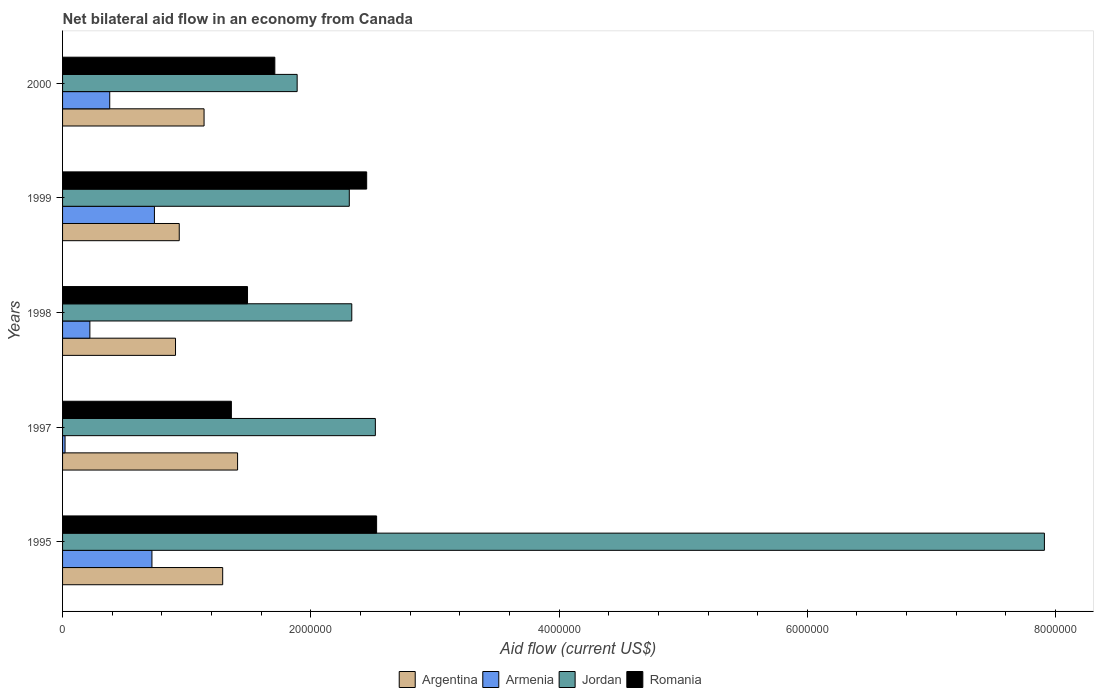How many different coloured bars are there?
Offer a very short reply. 4. How many groups of bars are there?
Keep it short and to the point. 5. How many bars are there on the 5th tick from the top?
Make the answer very short. 4. How many bars are there on the 1st tick from the bottom?
Provide a succinct answer. 4. What is the label of the 4th group of bars from the top?
Your answer should be compact. 1997. What is the net bilateral aid flow in Romania in 1997?
Provide a succinct answer. 1.36e+06. Across all years, what is the maximum net bilateral aid flow in Romania?
Provide a short and direct response. 2.53e+06. Across all years, what is the minimum net bilateral aid flow in Jordan?
Keep it short and to the point. 1.89e+06. In which year was the net bilateral aid flow in Armenia minimum?
Provide a succinct answer. 1997. What is the total net bilateral aid flow in Armenia in the graph?
Your answer should be very brief. 2.08e+06. What is the difference between the net bilateral aid flow in Armenia in 1995 and the net bilateral aid flow in Argentina in 1999?
Ensure brevity in your answer.  -2.20e+05. What is the average net bilateral aid flow in Romania per year?
Your answer should be very brief. 1.91e+06. In the year 1999, what is the difference between the net bilateral aid flow in Jordan and net bilateral aid flow in Armenia?
Make the answer very short. 1.57e+06. In how many years, is the net bilateral aid flow in Armenia greater than 800000 US$?
Your response must be concise. 0. What is the ratio of the net bilateral aid flow in Romania in 1997 to that in 1999?
Make the answer very short. 0.56. Is the net bilateral aid flow in Argentina in 1995 less than that in 2000?
Make the answer very short. No. What is the difference between the highest and the second highest net bilateral aid flow in Armenia?
Keep it short and to the point. 2.00e+04. What is the difference between the highest and the lowest net bilateral aid flow in Romania?
Keep it short and to the point. 1.17e+06. Is the sum of the net bilateral aid flow in Argentina in 1997 and 1998 greater than the maximum net bilateral aid flow in Armenia across all years?
Your response must be concise. Yes. What does the 3rd bar from the top in 2000 represents?
Provide a short and direct response. Armenia. What does the 4th bar from the bottom in 1995 represents?
Your response must be concise. Romania. How many bars are there?
Your response must be concise. 20. Are all the bars in the graph horizontal?
Your response must be concise. Yes. How many years are there in the graph?
Your response must be concise. 5. Are the values on the major ticks of X-axis written in scientific E-notation?
Your answer should be compact. No. How are the legend labels stacked?
Provide a short and direct response. Horizontal. What is the title of the graph?
Offer a terse response. Net bilateral aid flow in an economy from Canada. What is the label or title of the X-axis?
Your answer should be compact. Aid flow (current US$). What is the label or title of the Y-axis?
Your answer should be very brief. Years. What is the Aid flow (current US$) in Argentina in 1995?
Your answer should be compact. 1.29e+06. What is the Aid flow (current US$) in Armenia in 1995?
Offer a terse response. 7.20e+05. What is the Aid flow (current US$) of Jordan in 1995?
Your answer should be very brief. 7.91e+06. What is the Aid flow (current US$) of Romania in 1995?
Provide a succinct answer. 2.53e+06. What is the Aid flow (current US$) of Argentina in 1997?
Provide a succinct answer. 1.41e+06. What is the Aid flow (current US$) in Armenia in 1997?
Keep it short and to the point. 2.00e+04. What is the Aid flow (current US$) of Jordan in 1997?
Your response must be concise. 2.52e+06. What is the Aid flow (current US$) of Romania in 1997?
Provide a short and direct response. 1.36e+06. What is the Aid flow (current US$) of Argentina in 1998?
Give a very brief answer. 9.10e+05. What is the Aid flow (current US$) of Armenia in 1998?
Make the answer very short. 2.20e+05. What is the Aid flow (current US$) of Jordan in 1998?
Your response must be concise. 2.33e+06. What is the Aid flow (current US$) of Romania in 1998?
Ensure brevity in your answer.  1.49e+06. What is the Aid flow (current US$) of Argentina in 1999?
Offer a terse response. 9.40e+05. What is the Aid flow (current US$) in Armenia in 1999?
Make the answer very short. 7.40e+05. What is the Aid flow (current US$) in Jordan in 1999?
Provide a succinct answer. 2.31e+06. What is the Aid flow (current US$) in Romania in 1999?
Provide a succinct answer. 2.45e+06. What is the Aid flow (current US$) of Argentina in 2000?
Offer a very short reply. 1.14e+06. What is the Aid flow (current US$) of Armenia in 2000?
Make the answer very short. 3.80e+05. What is the Aid flow (current US$) in Jordan in 2000?
Your response must be concise. 1.89e+06. What is the Aid flow (current US$) in Romania in 2000?
Give a very brief answer. 1.71e+06. Across all years, what is the maximum Aid flow (current US$) of Argentina?
Give a very brief answer. 1.41e+06. Across all years, what is the maximum Aid flow (current US$) of Armenia?
Provide a succinct answer. 7.40e+05. Across all years, what is the maximum Aid flow (current US$) in Jordan?
Offer a very short reply. 7.91e+06. Across all years, what is the maximum Aid flow (current US$) of Romania?
Provide a short and direct response. 2.53e+06. Across all years, what is the minimum Aid flow (current US$) of Argentina?
Keep it short and to the point. 9.10e+05. Across all years, what is the minimum Aid flow (current US$) in Jordan?
Your answer should be very brief. 1.89e+06. Across all years, what is the minimum Aid flow (current US$) of Romania?
Provide a short and direct response. 1.36e+06. What is the total Aid flow (current US$) of Argentina in the graph?
Provide a short and direct response. 5.69e+06. What is the total Aid flow (current US$) of Armenia in the graph?
Offer a very short reply. 2.08e+06. What is the total Aid flow (current US$) of Jordan in the graph?
Offer a very short reply. 1.70e+07. What is the total Aid flow (current US$) in Romania in the graph?
Provide a succinct answer. 9.54e+06. What is the difference between the Aid flow (current US$) of Armenia in 1995 and that in 1997?
Provide a succinct answer. 7.00e+05. What is the difference between the Aid flow (current US$) in Jordan in 1995 and that in 1997?
Offer a very short reply. 5.39e+06. What is the difference between the Aid flow (current US$) of Romania in 1995 and that in 1997?
Give a very brief answer. 1.17e+06. What is the difference between the Aid flow (current US$) in Argentina in 1995 and that in 1998?
Keep it short and to the point. 3.80e+05. What is the difference between the Aid flow (current US$) in Jordan in 1995 and that in 1998?
Ensure brevity in your answer.  5.58e+06. What is the difference between the Aid flow (current US$) in Romania in 1995 and that in 1998?
Ensure brevity in your answer.  1.04e+06. What is the difference between the Aid flow (current US$) of Armenia in 1995 and that in 1999?
Give a very brief answer. -2.00e+04. What is the difference between the Aid flow (current US$) in Jordan in 1995 and that in 1999?
Keep it short and to the point. 5.60e+06. What is the difference between the Aid flow (current US$) of Romania in 1995 and that in 1999?
Make the answer very short. 8.00e+04. What is the difference between the Aid flow (current US$) of Jordan in 1995 and that in 2000?
Give a very brief answer. 6.02e+06. What is the difference between the Aid flow (current US$) of Romania in 1995 and that in 2000?
Make the answer very short. 8.20e+05. What is the difference between the Aid flow (current US$) of Romania in 1997 and that in 1998?
Provide a succinct answer. -1.30e+05. What is the difference between the Aid flow (current US$) in Argentina in 1997 and that in 1999?
Provide a succinct answer. 4.70e+05. What is the difference between the Aid flow (current US$) of Armenia in 1997 and that in 1999?
Your answer should be compact. -7.20e+05. What is the difference between the Aid flow (current US$) of Jordan in 1997 and that in 1999?
Your answer should be compact. 2.10e+05. What is the difference between the Aid flow (current US$) in Romania in 1997 and that in 1999?
Your answer should be compact. -1.09e+06. What is the difference between the Aid flow (current US$) in Armenia in 1997 and that in 2000?
Offer a very short reply. -3.60e+05. What is the difference between the Aid flow (current US$) in Jordan in 1997 and that in 2000?
Provide a succinct answer. 6.30e+05. What is the difference between the Aid flow (current US$) in Romania in 1997 and that in 2000?
Make the answer very short. -3.50e+05. What is the difference between the Aid flow (current US$) in Armenia in 1998 and that in 1999?
Give a very brief answer. -5.20e+05. What is the difference between the Aid flow (current US$) in Romania in 1998 and that in 1999?
Provide a short and direct response. -9.60e+05. What is the difference between the Aid flow (current US$) in Argentina in 1998 and that in 2000?
Offer a very short reply. -2.30e+05. What is the difference between the Aid flow (current US$) of Armenia in 1998 and that in 2000?
Your answer should be compact. -1.60e+05. What is the difference between the Aid flow (current US$) of Romania in 1998 and that in 2000?
Provide a short and direct response. -2.20e+05. What is the difference between the Aid flow (current US$) in Armenia in 1999 and that in 2000?
Ensure brevity in your answer.  3.60e+05. What is the difference between the Aid flow (current US$) in Romania in 1999 and that in 2000?
Make the answer very short. 7.40e+05. What is the difference between the Aid flow (current US$) in Argentina in 1995 and the Aid flow (current US$) in Armenia in 1997?
Provide a succinct answer. 1.27e+06. What is the difference between the Aid flow (current US$) in Argentina in 1995 and the Aid flow (current US$) in Jordan in 1997?
Offer a very short reply. -1.23e+06. What is the difference between the Aid flow (current US$) in Argentina in 1995 and the Aid flow (current US$) in Romania in 1997?
Make the answer very short. -7.00e+04. What is the difference between the Aid flow (current US$) of Armenia in 1995 and the Aid flow (current US$) of Jordan in 1997?
Make the answer very short. -1.80e+06. What is the difference between the Aid flow (current US$) of Armenia in 1995 and the Aid flow (current US$) of Romania in 1997?
Your answer should be compact. -6.40e+05. What is the difference between the Aid flow (current US$) of Jordan in 1995 and the Aid flow (current US$) of Romania in 1997?
Your response must be concise. 6.55e+06. What is the difference between the Aid flow (current US$) of Argentina in 1995 and the Aid flow (current US$) of Armenia in 1998?
Offer a terse response. 1.07e+06. What is the difference between the Aid flow (current US$) of Argentina in 1995 and the Aid flow (current US$) of Jordan in 1998?
Your response must be concise. -1.04e+06. What is the difference between the Aid flow (current US$) of Armenia in 1995 and the Aid flow (current US$) of Jordan in 1998?
Offer a terse response. -1.61e+06. What is the difference between the Aid flow (current US$) of Armenia in 1995 and the Aid flow (current US$) of Romania in 1998?
Offer a very short reply. -7.70e+05. What is the difference between the Aid flow (current US$) in Jordan in 1995 and the Aid flow (current US$) in Romania in 1998?
Ensure brevity in your answer.  6.42e+06. What is the difference between the Aid flow (current US$) in Argentina in 1995 and the Aid flow (current US$) in Jordan in 1999?
Keep it short and to the point. -1.02e+06. What is the difference between the Aid flow (current US$) in Argentina in 1995 and the Aid flow (current US$) in Romania in 1999?
Provide a short and direct response. -1.16e+06. What is the difference between the Aid flow (current US$) in Armenia in 1995 and the Aid flow (current US$) in Jordan in 1999?
Offer a terse response. -1.59e+06. What is the difference between the Aid flow (current US$) of Armenia in 1995 and the Aid flow (current US$) of Romania in 1999?
Provide a succinct answer. -1.73e+06. What is the difference between the Aid flow (current US$) of Jordan in 1995 and the Aid flow (current US$) of Romania in 1999?
Ensure brevity in your answer.  5.46e+06. What is the difference between the Aid flow (current US$) of Argentina in 1995 and the Aid flow (current US$) of Armenia in 2000?
Ensure brevity in your answer.  9.10e+05. What is the difference between the Aid flow (current US$) of Argentina in 1995 and the Aid flow (current US$) of Jordan in 2000?
Provide a short and direct response. -6.00e+05. What is the difference between the Aid flow (current US$) of Argentina in 1995 and the Aid flow (current US$) of Romania in 2000?
Offer a terse response. -4.20e+05. What is the difference between the Aid flow (current US$) in Armenia in 1995 and the Aid flow (current US$) in Jordan in 2000?
Your response must be concise. -1.17e+06. What is the difference between the Aid flow (current US$) of Armenia in 1995 and the Aid flow (current US$) of Romania in 2000?
Provide a short and direct response. -9.90e+05. What is the difference between the Aid flow (current US$) of Jordan in 1995 and the Aid flow (current US$) of Romania in 2000?
Offer a very short reply. 6.20e+06. What is the difference between the Aid flow (current US$) of Argentina in 1997 and the Aid flow (current US$) of Armenia in 1998?
Your answer should be very brief. 1.19e+06. What is the difference between the Aid flow (current US$) of Argentina in 1997 and the Aid flow (current US$) of Jordan in 1998?
Make the answer very short. -9.20e+05. What is the difference between the Aid flow (current US$) of Armenia in 1997 and the Aid flow (current US$) of Jordan in 1998?
Offer a terse response. -2.31e+06. What is the difference between the Aid flow (current US$) of Armenia in 1997 and the Aid flow (current US$) of Romania in 1998?
Your response must be concise. -1.47e+06. What is the difference between the Aid flow (current US$) of Jordan in 1997 and the Aid flow (current US$) of Romania in 1998?
Your response must be concise. 1.03e+06. What is the difference between the Aid flow (current US$) of Argentina in 1997 and the Aid flow (current US$) of Armenia in 1999?
Your answer should be compact. 6.70e+05. What is the difference between the Aid flow (current US$) in Argentina in 1997 and the Aid flow (current US$) in Jordan in 1999?
Provide a succinct answer. -9.00e+05. What is the difference between the Aid flow (current US$) in Argentina in 1997 and the Aid flow (current US$) in Romania in 1999?
Your answer should be very brief. -1.04e+06. What is the difference between the Aid flow (current US$) of Armenia in 1997 and the Aid flow (current US$) of Jordan in 1999?
Provide a succinct answer. -2.29e+06. What is the difference between the Aid flow (current US$) in Armenia in 1997 and the Aid flow (current US$) in Romania in 1999?
Keep it short and to the point. -2.43e+06. What is the difference between the Aid flow (current US$) of Jordan in 1997 and the Aid flow (current US$) of Romania in 1999?
Provide a succinct answer. 7.00e+04. What is the difference between the Aid flow (current US$) of Argentina in 1997 and the Aid flow (current US$) of Armenia in 2000?
Your response must be concise. 1.03e+06. What is the difference between the Aid flow (current US$) in Argentina in 1997 and the Aid flow (current US$) in Jordan in 2000?
Give a very brief answer. -4.80e+05. What is the difference between the Aid flow (current US$) in Armenia in 1997 and the Aid flow (current US$) in Jordan in 2000?
Ensure brevity in your answer.  -1.87e+06. What is the difference between the Aid flow (current US$) of Armenia in 1997 and the Aid flow (current US$) of Romania in 2000?
Give a very brief answer. -1.69e+06. What is the difference between the Aid flow (current US$) in Jordan in 1997 and the Aid flow (current US$) in Romania in 2000?
Offer a very short reply. 8.10e+05. What is the difference between the Aid flow (current US$) of Argentina in 1998 and the Aid flow (current US$) of Armenia in 1999?
Provide a short and direct response. 1.70e+05. What is the difference between the Aid flow (current US$) of Argentina in 1998 and the Aid flow (current US$) of Jordan in 1999?
Provide a short and direct response. -1.40e+06. What is the difference between the Aid flow (current US$) of Argentina in 1998 and the Aid flow (current US$) of Romania in 1999?
Make the answer very short. -1.54e+06. What is the difference between the Aid flow (current US$) in Armenia in 1998 and the Aid flow (current US$) in Jordan in 1999?
Give a very brief answer. -2.09e+06. What is the difference between the Aid flow (current US$) in Armenia in 1998 and the Aid flow (current US$) in Romania in 1999?
Your answer should be compact. -2.23e+06. What is the difference between the Aid flow (current US$) of Argentina in 1998 and the Aid flow (current US$) of Armenia in 2000?
Your answer should be compact. 5.30e+05. What is the difference between the Aid flow (current US$) of Argentina in 1998 and the Aid flow (current US$) of Jordan in 2000?
Provide a short and direct response. -9.80e+05. What is the difference between the Aid flow (current US$) in Argentina in 1998 and the Aid flow (current US$) in Romania in 2000?
Provide a short and direct response. -8.00e+05. What is the difference between the Aid flow (current US$) of Armenia in 1998 and the Aid flow (current US$) of Jordan in 2000?
Provide a short and direct response. -1.67e+06. What is the difference between the Aid flow (current US$) of Armenia in 1998 and the Aid flow (current US$) of Romania in 2000?
Offer a terse response. -1.49e+06. What is the difference between the Aid flow (current US$) in Jordan in 1998 and the Aid flow (current US$) in Romania in 2000?
Offer a terse response. 6.20e+05. What is the difference between the Aid flow (current US$) of Argentina in 1999 and the Aid flow (current US$) of Armenia in 2000?
Provide a short and direct response. 5.60e+05. What is the difference between the Aid flow (current US$) in Argentina in 1999 and the Aid flow (current US$) in Jordan in 2000?
Offer a terse response. -9.50e+05. What is the difference between the Aid flow (current US$) of Argentina in 1999 and the Aid flow (current US$) of Romania in 2000?
Offer a terse response. -7.70e+05. What is the difference between the Aid flow (current US$) of Armenia in 1999 and the Aid flow (current US$) of Jordan in 2000?
Give a very brief answer. -1.15e+06. What is the difference between the Aid flow (current US$) in Armenia in 1999 and the Aid flow (current US$) in Romania in 2000?
Offer a terse response. -9.70e+05. What is the difference between the Aid flow (current US$) of Jordan in 1999 and the Aid flow (current US$) of Romania in 2000?
Give a very brief answer. 6.00e+05. What is the average Aid flow (current US$) in Argentina per year?
Your answer should be very brief. 1.14e+06. What is the average Aid flow (current US$) of Armenia per year?
Provide a short and direct response. 4.16e+05. What is the average Aid flow (current US$) in Jordan per year?
Provide a short and direct response. 3.39e+06. What is the average Aid flow (current US$) of Romania per year?
Your answer should be compact. 1.91e+06. In the year 1995, what is the difference between the Aid flow (current US$) in Argentina and Aid flow (current US$) in Armenia?
Your answer should be compact. 5.70e+05. In the year 1995, what is the difference between the Aid flow (current US$) in Argentina and Aid flow (current US$) in Jordan?
Provide a short and direct response. -6.62e+06. In the year 1995, what is the difference between the Aid flow (current US$) of Argentina and Aid flow (current US$) of Romania?
Your answer should be compact. -1.24e+06. In the year 1995, what is the difference between the Aid flow (current US$) of Armenia and Aid flow (current US$) of Jordan?
Make the answer very short. -7.19e+06. In the year 1995, what is the difference between the Aid flow (current US$) of Armenia and Aid flow (current US$) of Romania?
Provide a short and direct response. -1.81e+06. In the year 1995, what is the difference between the Aid flow (current US$) in Jordan and Aid flow (current US$) in Romania?
Offer a very short reply. 5.38e+06. In the year 1997, what is the difference between the Aid flow (current US$) of Argentina and Aid flow (current US$) of Armenia?
Provide a succinct answer. 1.39e+06. In the year 1997, what is the difference between the Aid flow (current US$) in Argentina and Aid flow (current US$) in Jordan?
Your answer should be compact. -1.11e+06. In the year 1997, what is the difference between the Aid flow (current US$) in Argentina and Aid flow (current US$) in Romania?
Make the answer very short. 5.00e+04. In the year 1997, what is the difference between the Aid flow (current US$) in Armenia and Aid flow (current US$) in Jordan?
Your response must be concise. -2.50e+06. In the year 1997, what is the difference between the Aid flow (current US$) of Armenia and Aid flow (current US$) of Romania?
Provide a short and direct response. -1.34e+06. In the year 1997, what is the difference between the Aid flow (current US$) in Jordan and Aid flow (current US$) in Romania?
Make the answer very short. 1.16e+06. In the year 1998, what is the difference between the Aid flow (current US$) in Argentina and Aid flow (current US$) in Armenia?
Keep it short and to the point. 6.90e+05. In the year 1998, what is the difference between the Aid flow (current US$) of Argentina and Aid flow (current US$) of Jordan?
Make the answer very short. -1.42e+06. In the year 1998, what is the difference between the Aid flow (current US$) in Argentina and Aid flow (current US$) in Romania?
Ensure brevity in your answer.  -5.80e+05. In the year 1998, what is the difference between the Aid flow (current US$) in Armenia and Aid flow (current US$) in Jordan?
Give a very brief answer. -2.11e+06. In the year 1998, what is the difference between the Aid flow (current US$) in Armenia and Aid flow (current US$) in Romania?
Your answer should be very brief. -1.27e+06. In the year 1998, what is the difference between the Aid flow (current US$) of Jordan and Aid flow (current US$) of Romania?
Provide a succinct answer. 8.40e+05. In the year 1999, what is the difference between the Aid flow (current US$) of Argentina and Aid flow (current US$) of Jordan?
Your answer should be compact. -1.37e+06. In the year 1999, what is the difference between the Aid flow (current US$) in Argentina and Aid flow (current US$) in Romania?
Your answer should be compact. -1.51e+06. In the year 1999, what is the difference between the Aid flow (current US$) in Armenia and Aid flow (current US$) in Jordan?
Your response must be concise. -1.57e+06. In the year 1999, what is the difference between the Aid flow (current US$) in Armenia and Aid flow (current US$) in Romania?
Ensure brevity in your answer.  -1.71e+06. In the year 1999, what is the difference between the Aid flow (current US$) of Jordan and Aid flow (current US$) of Romania?
Offer a very short reply. -1.40e+05. In the year 2000, what is the difference between the Aid flow (current US$) in Argentina and Aid flow (current US$) in Armenia?
Your response must be concise. 7.60e+05. In the year 2000, what is the difference between the Aid flow (current US$) in Argentina and Aid flow (current US$) in Jordan?
Keep it short and to the point. -7.50e+05. In the year 2000, what is the difference between the Aid flow (current US$) of Argentina and Aid flow (current US$) of Romania?
Provide a succinct answer. -5.70e+05. In the year 2000, what is the difference between the Aid flow (current US$) of Armenia and Aid flow (current US$) of Jordan?
Your answer should be compact. -1.51e+06. In the year 2000, what is the difference between the Aid flow (current US$) in Armenia and Aid flow (current US$) in Romania?
Give a very brief answer. -1.33e+06. What is the ratio of the Aid flow (current US$) of Argentina in 1995 to that in 1997?
Keep it short and to the point. 0.91. What is the ratio of the Aid flow (current US$) of Armenia in 1995 to that in 1997?
Offer a very short reply. 36. What is the ratio of the Aid flow (current US$) of Jordan in 1995 to that in 1997?
Your answer should be compact. 3.14. What is the ratio of the Aid flow (current US$) in Romania in 1995 to that in 1997?
Your answer should be compact. 1.86. What is the ratio of the Aid flow (current US$) of Argentina in 1995 to that in 1998?
Give a very brief answer. 1.42. What is the ratio of the Aid flow (current US$) in Armenia in 1995 to that in 1998?
Provide a short and direct response. 3.27. What is the ratio of the Aid flow (current US$) in Jordan in 1995 to that in 1998?
Give a very brief answer. 3.39. What is the ratio of the Aid flow (current US$) in Romania in 1995 to that in 1998?
Give a very brief answer. 1.7. What is the ratio of the Aid flow (current US$) in Argentina in 1995 to that in 1999?
Offer a very short reply. 1.37. What is the ratio of the Aid flow (current US$) in Jordan in 1995 to that in 1999?
Make the answer very short. 3.42. What is the ratio of the Aid flow (current US$) in Romania in 1995 to that in 1999?
Keep it short and to the point. 1.03. What is the ratio of the Aid flow (current US$) of Argentina in 1995 to that in 2000?
Your response must be concise. 1.13. What is the ratio of the Aid flow (current US$) of Armenia in 1995 to that in 2000?
Make the answer very short. 1.89. What is the ratio of the Aid flow (current US$) of Jordan in 1995 to that in 2000?
Your answer should be very brief. 4.19. What is the ratio of the Aid flow (current US$) of Romania in 1995 to that in 2000?
Offer a very short reply. 1.48. What is the ratio of the Aid flow (current US$) in Argentina in 1997 to that in 1998?
Give a very brief answer. 1.55. What is the ratio of the Aid flow (current US$) in Armenia in 1997 to that in 1998?
Keep it short and to the point. 0.09. What is the ratio of the Aid flow (current US$) of Jordan in 1997 to that in 1998?
Give a very brief answer. 1.08. What is the ratio of the Aid flow (current US$) of Romania in 1997 to that in 1998?
Offer a terse response. 0.91. What is the ratio of the Aid flow (current US$) of Armenia in 1997 to that in 1999?
Offer a terse response. 0.03. What is the ratio of the Aid flow (current US$) of Romania in 1997 to that in 1999?
Offer a very short reply. 0.56. What is the ratio of the Aid flow (current US$) in Argentina in 1997 to that in 2000?
Keep it short and to the point. 1.24. What is the ratio of the Aid flow (current US$) in Armenia in 1997 to that in 2000?
Provide a succinct answer. 0.05. What is the ratio of the Aid flow (current US$) of Jordan in 1997 to that in 2000?
Your response must be concise. 1.33. What is the ratio of the Aid flow (current US$) in Romania in 1997 to that in 2000?
Ensure brevity in your answer.  0.8. What is the ratio of the Aid flow (current US$) in Argentina in 1998 to that in 1999?
Your response must be concise. 0.97. What is the ratio of the Aid flow (current US$) of Armenia in 1998 to that in 1999?
Provide a short and direct response. 0.3. What is the ratio of the Aid flow (current US$) in Jordan in 1998 to that in 1999?
Provide a succinct answer. 1.01. What is the ratio of the Aid flow (current US$) of Romania in 1998 to that in 1999?
Your answer should be compact. 0.61. What is the ratio of the Aid flow (current US$) in Argentina in 1998 to that in 2000?
Keep it short and to the point. 0.8. What is the ratio of the Aid flow (current US$) of Armenia in 1998 to that in 2000?
Offer a terse response. 0.58. What is the ratio of the Aid flow (current US$) of Jordan in 1998 to that in 2000?
Provide a short and direct response. 1.23. What is the ratio of the Aid flow (current US$) of Romania in 1998 to that in 2000?
Provide a short and direct response. 0.87. What is the ratio of the Aid flow (current US$) of Argentina in 1999 to that in 2000?
Your answer should be compact. 0.82. What is the ratio of the Aid flow (current US$) in Armenia in 1999 to that in 2000?
Make the answer very short. 1.95. What is the ratio of the Aid flow (current US$) in Jordan in 1999 to that in 2000?
Offer a terse response. 1.22. What is the ratio of the Aid flow (current US$) in Romania in 1999 to that in 2000?
Your answer should be very brief. 1.43. What is the difference between the highest and the second highest Aid flow (current US$) in Jordan?
Offer a very short reply. 5.39e+06. What is the difference between the highest and the lowest Aid flow (current US$) in Armenia?
Provide a succinct answer. 7.20e+05. What is the difference between the highest and the lowest Aid flow (current US$) in Jordan?
Offer a terse response. 6.02e+06. What is the difference between the highest and the lowest Aid flow (current US$) in Romania?
Your response must be concise. 1.17e+06. 